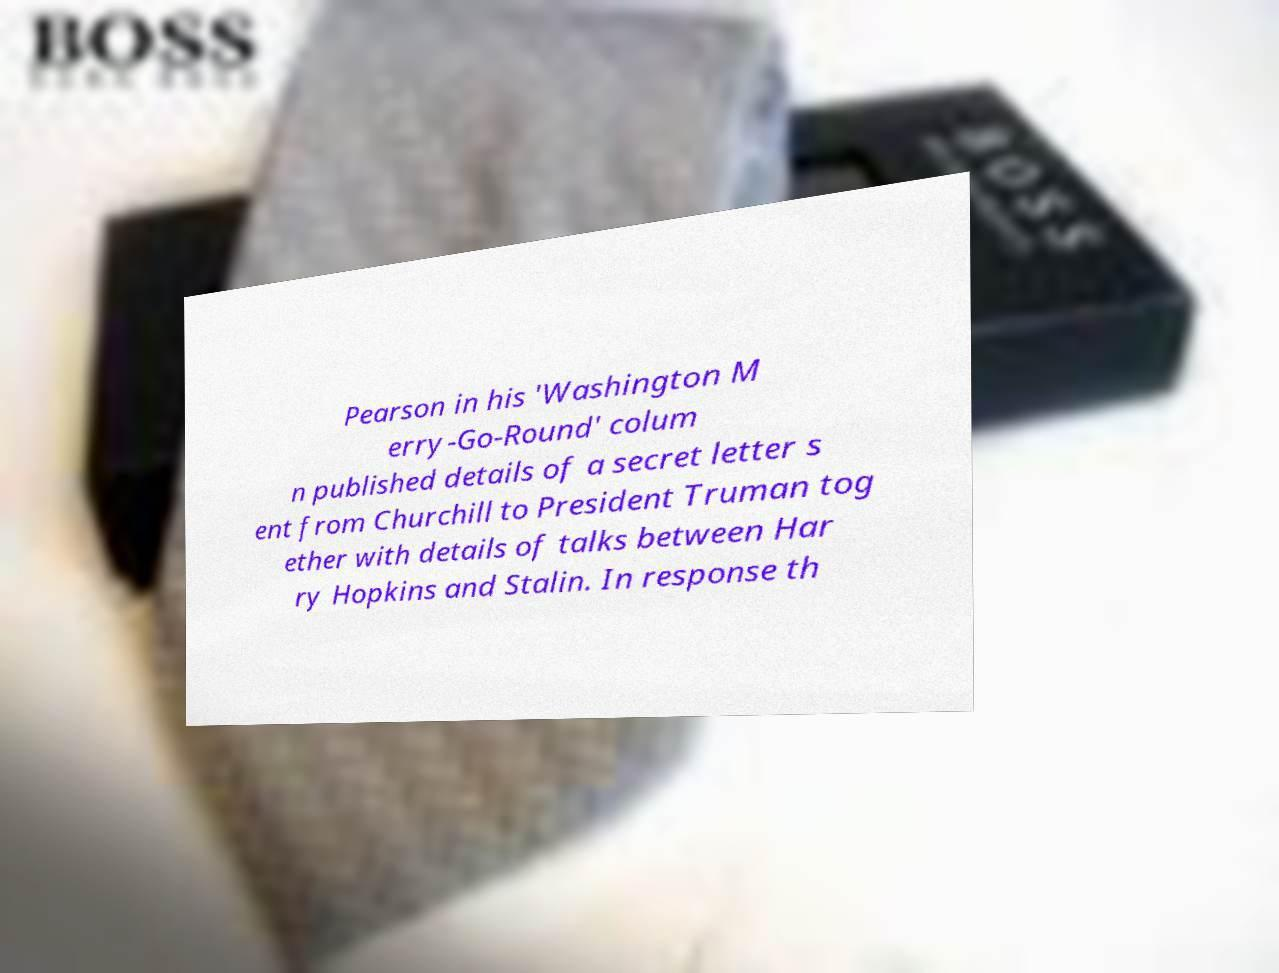There's text embedded in this image that I need extracted. Can you transcribe it verbatim? Pearson in his 'Washington M erry-Go-Round' colum n published details of a secret letter s ent from Churchill to President Truman tog ether with details of talks between Har ry Hopkins and Stalin. In response th 